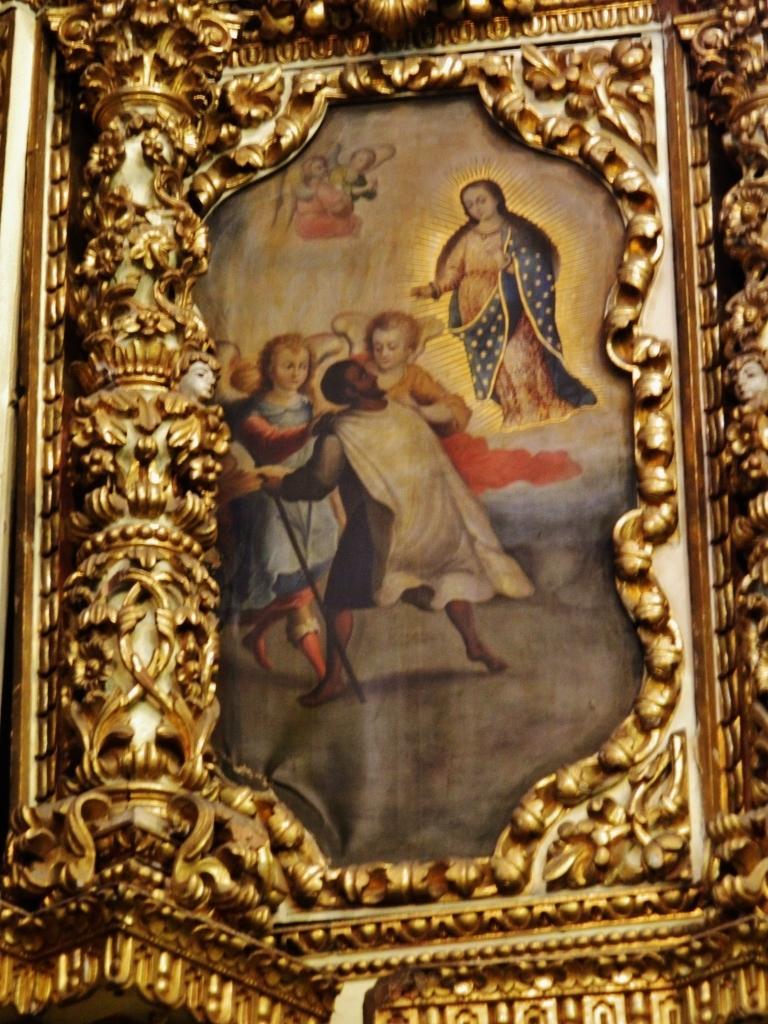Could you give a brief overview of what you see in this image? In the center of the image there is a photo frame in which there are persons. 